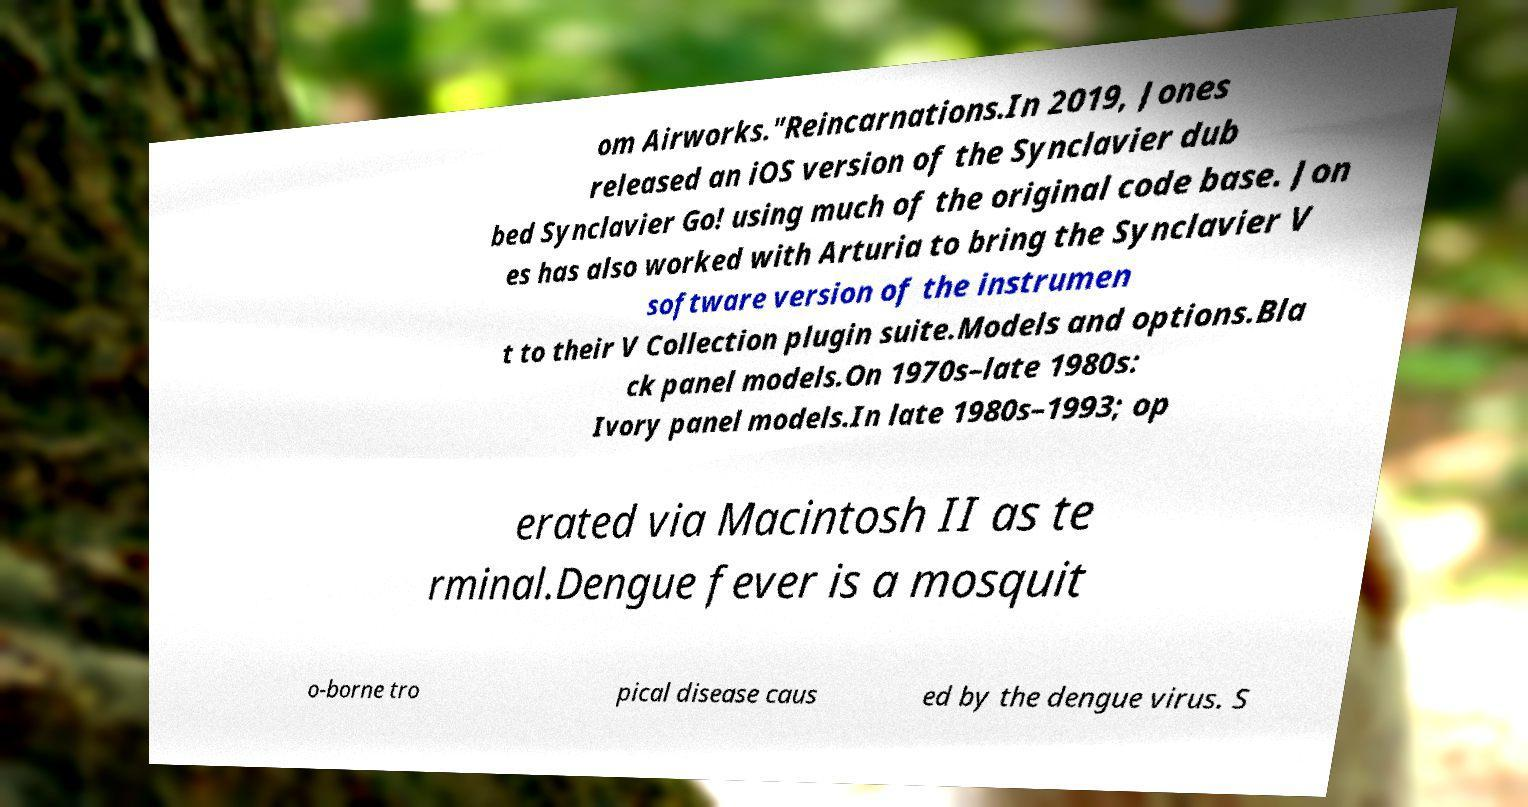What messages or text are displayed in this image? I need them in a readable, typed format. om Airworks."Reincarnations.In 2019, Jones released an iOS version of the Synclavier dub bed Synclavier Go! using much of the original code base. Jon es has also worked with Arturia to bring the Synclavier V software version of the instrumen t to their V Collection plugin suite.Models and options.Bla ck panel models.On 1970s–late 1980s: Ivory panel models.In late 1980s–1993; op erated via Macintosh II as te rminal.Dengue fever is a mosquit o-borne tro pical disease caus ed by the dengue virus. S 